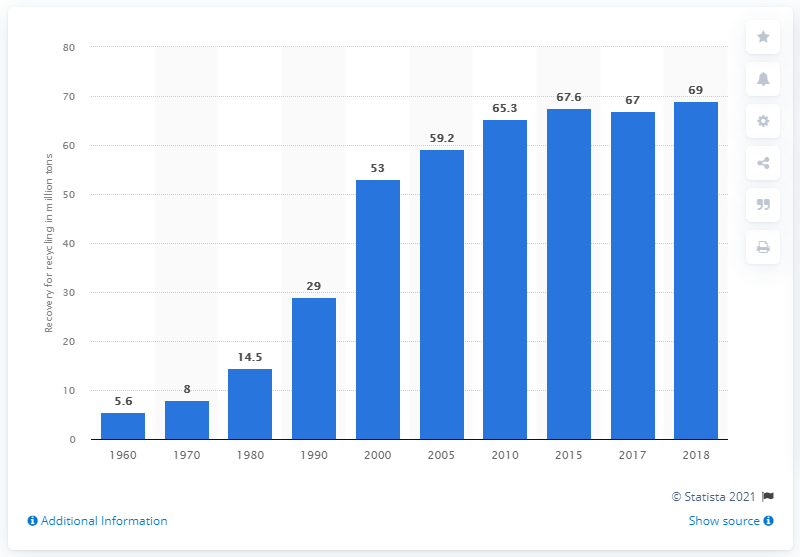Highlight a few significant elements in this photo. In 2018, 69% of municipal solid waste (MSW) was recovered for recycling. In 1970, one of the first mass recycling programs in the United States was implemented. 